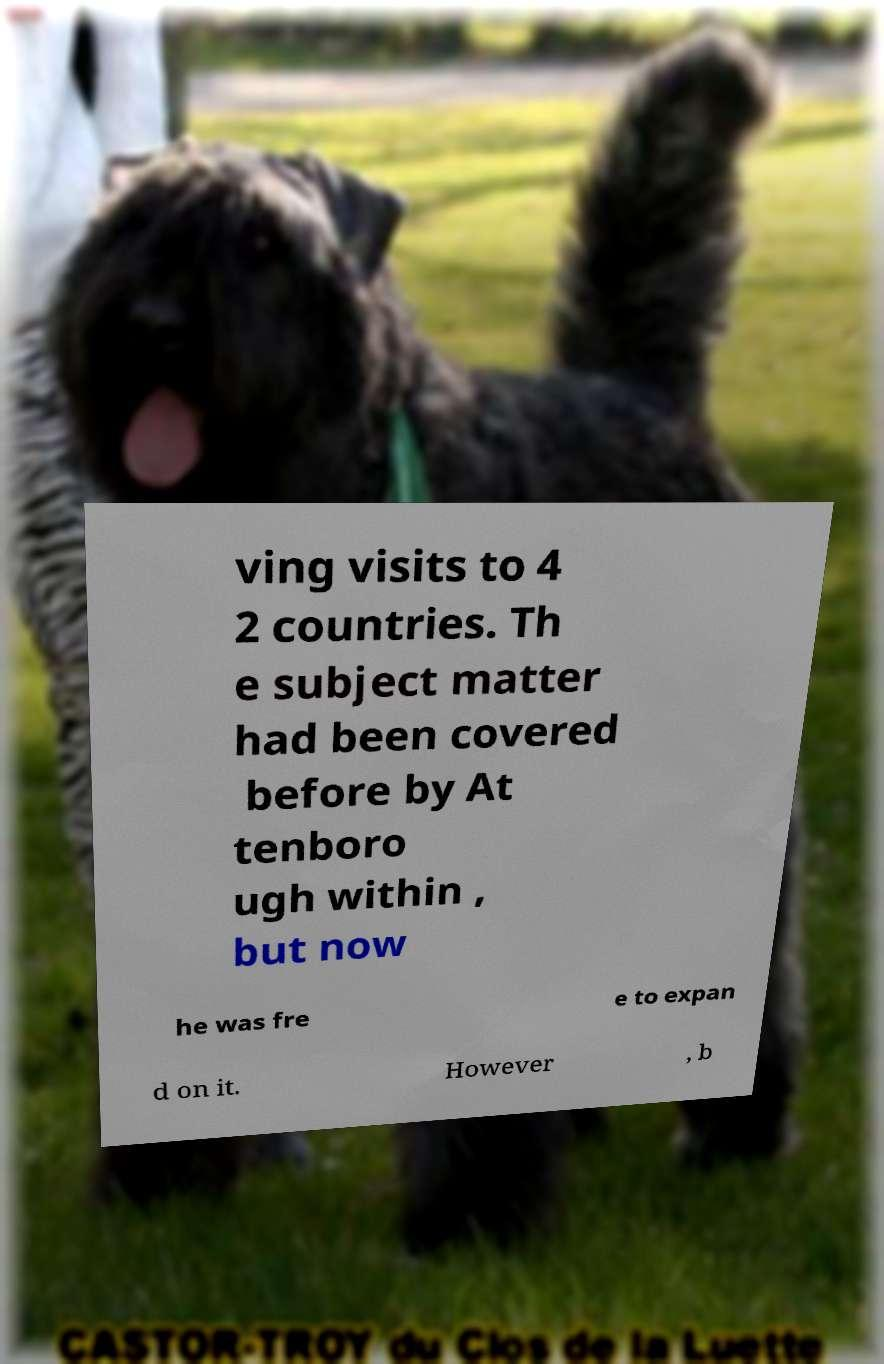Please identify and transcribe the text found in this image. ving visits to 4 2 countries. Th e subject matter had been covered before by At tenboro ugh within , but now he was fre e to expan d on it. However , b 